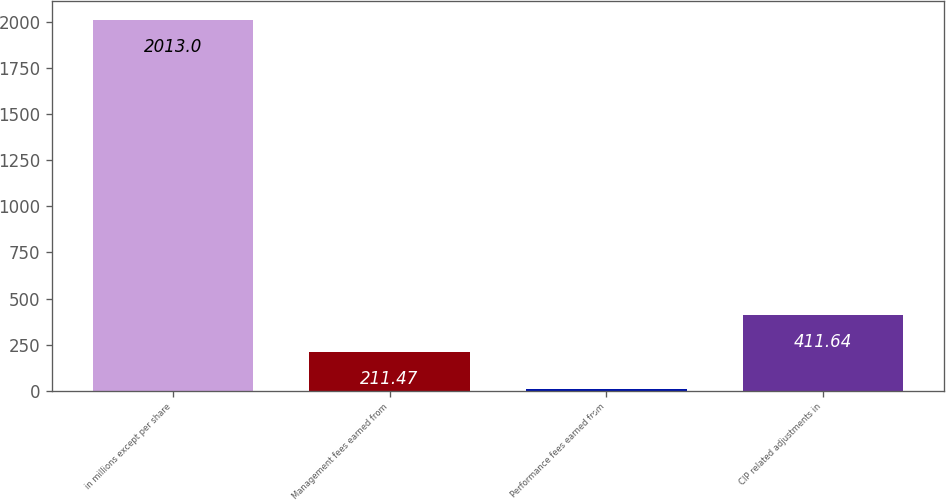Convert chart. <chart><loc_0><loc_0><loc_500><loc_500><bar_chart><fcel>in millions except per share<fcel>Management fees earned from<fcel>Performance fees earned from<fcel>CIP related adjustments in<nl><fcel>2013<fcel>211.47<fcel>11.3<fcel>411.64<nl></chart> 